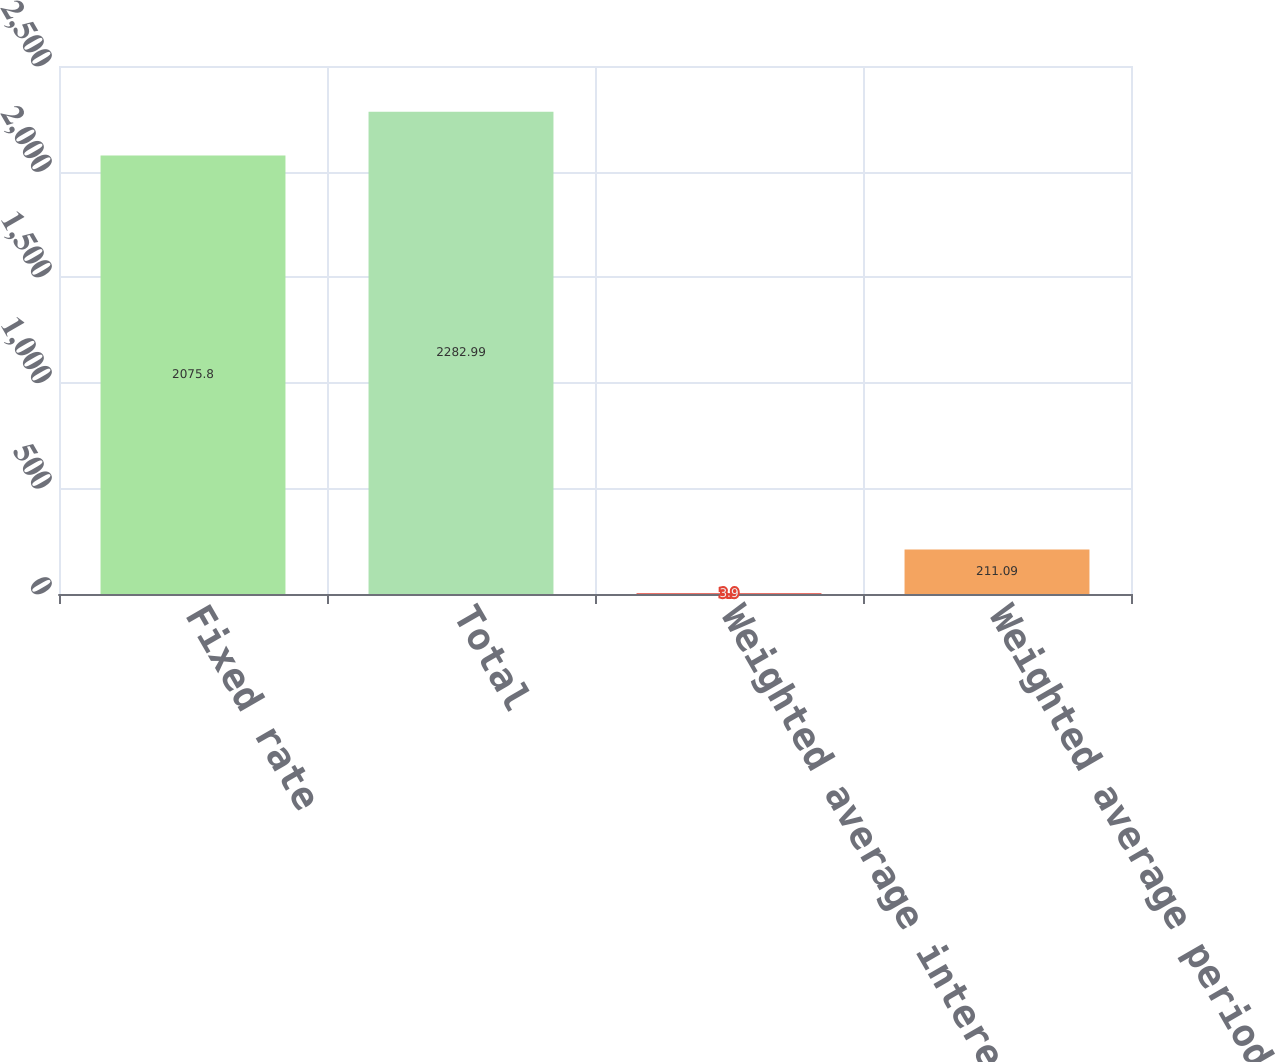Convert chart. <chart><loc_0><loc_0><loc_500><loc_500><bar_chart><fcel>Fixed rate<fcel>Total<fcel>Weighted average interest rate<fcel>Weighted average period for<nl><fcel>2075.8<fcel>2282.99<fcel>3.9<fcel>211.09<nl></chart> 